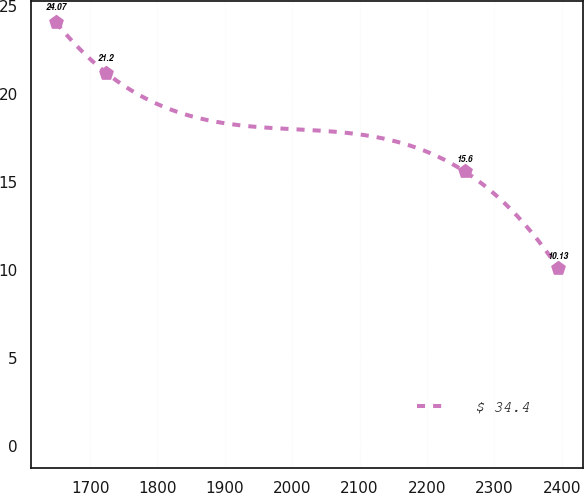Convert chart. <chart><loc_0><loc_0><loc_500><loc_500><line_chart><ecel><fcel>$ 34.4<nl><fcel>1649.31<fcel>24.07<nl><fcel>1723.84<fcel>21.2<nl><fcel>2256.05<fcel>15.6<nl><fcel>2394.58<fcel>10.13<nl></chart> 